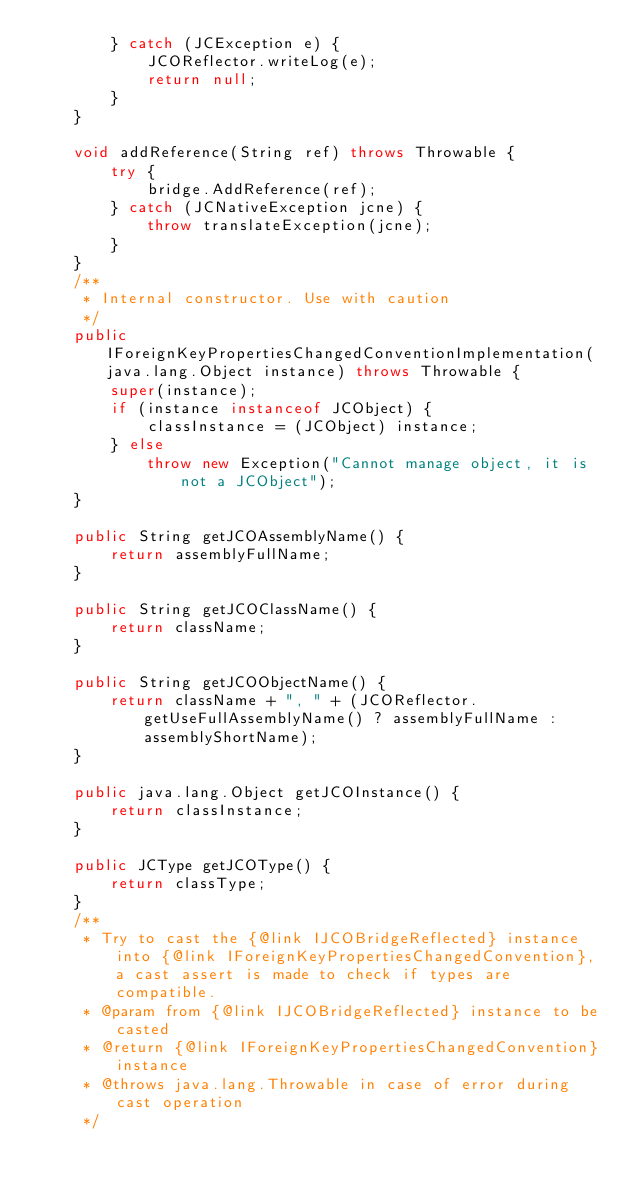Convert code to text. <code><loc_0><loc_0><loc_500><loc_500><_Java_>        } catch (JCException e) {
            JCOReflector.writeLog(e);
            return null;
        }
    }

    void addReference(String ref) throws Throwable {
        try {
            bridge.AddReference(ref);
        } catch (JCNativeException jcne) {
            throw translateException(jcne);
        }
    }
    /**
     * Internal constructor. Use with caution 
     */
    public IForeignKeyPropertiesChangedConventionImplementation(java.lang.Object instance) throws Throwable {
        super(instance);
        if (instance instanceof JCObject) {
            classInstance = (JCObject) instance;
        } else
            throw new Exception("Cannot manage object, it is not a JCObject");
    }

    public String getJCOAssemblyName() {
        return assemblyFullName;
    }

    public String getJCOClassName() {
        return className;
    }

    public String getJCOObjectName() {
        return className + ", " + (JCOReflector.getUseFullAssemblyName() ? assemblyFullName : assemblyShortName);
    }

    public java.lang.Object getJCOInstance() {
        return classInstance;
    }

    public JCType getJCOType() {
        return classType;
    }
    /**
     * Try to cast the {@link IJCOBridgeReflected} instance into {@link IForeignKeyPropertiesChangedConvention}, a cast assert is made to check if types are compatible.
     * @param from {@link IJCOBridgeReflected} instance to be casted
     * @return {@link IForeignKeyPropertiesChangedConvention} instance
     * @throws java.lang.Throwable in case of error during cast operation
     */</code> 